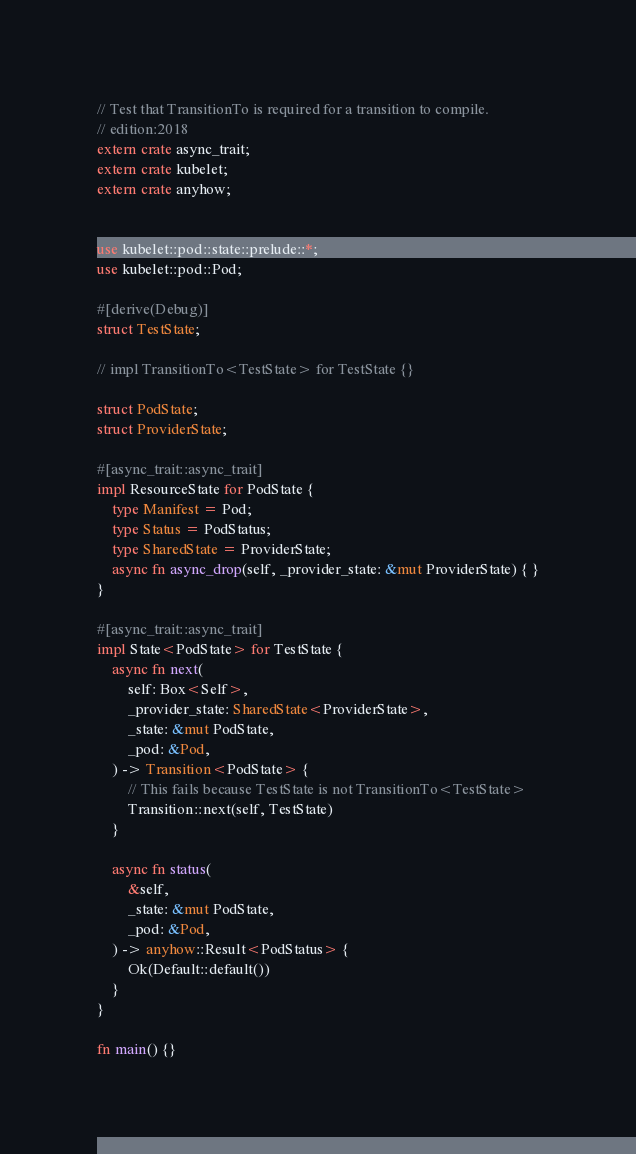<code> <loc_0><loc_0><loc_500><loc_500><_Rust_>// Test that TransitionTo is required for a transition to compile. 
// edition:2018
extern crate async_trait;
extern crate kubelet;
extern crate anyhow;


use kubelet::pod::state::prelude::*;
use kubelet::pod::Pod;

#[derive(Debug)]
struct TestState;

// impl TransitionTo<TestState> for TestState {}

struct PodState;
struct ProviderState;

#[async_trait::async_trait]
impl ResourceState for PodState {
    type Manifest = Pod;
    type Status = PodStatus;
    type SharedState = ProviderState;
    async fn async_drop(self, _provider_state: &mut ProviderState) { }
}

#[async_trait::async_trait]
impl State<PodState> for TestState {
    async fn next(
        self: Box<Self>,
        _provider_state: SharedState<ProviderState>,
        _state: &mut PodState,
        _pod: &Pod,
    ) -> Transition<PodState> {
        // This fails because TestState is not TransitionTo<TestState>
        Transition::next(self, TestState)
    }

    async fn status(
        &self,
        _state: &mut PodState,
        _pod: &Pod,
    ) -> anyhow::Result<PodStatus> {
        Ok(Default::default())
    }
}

fn main() {}
</code> 